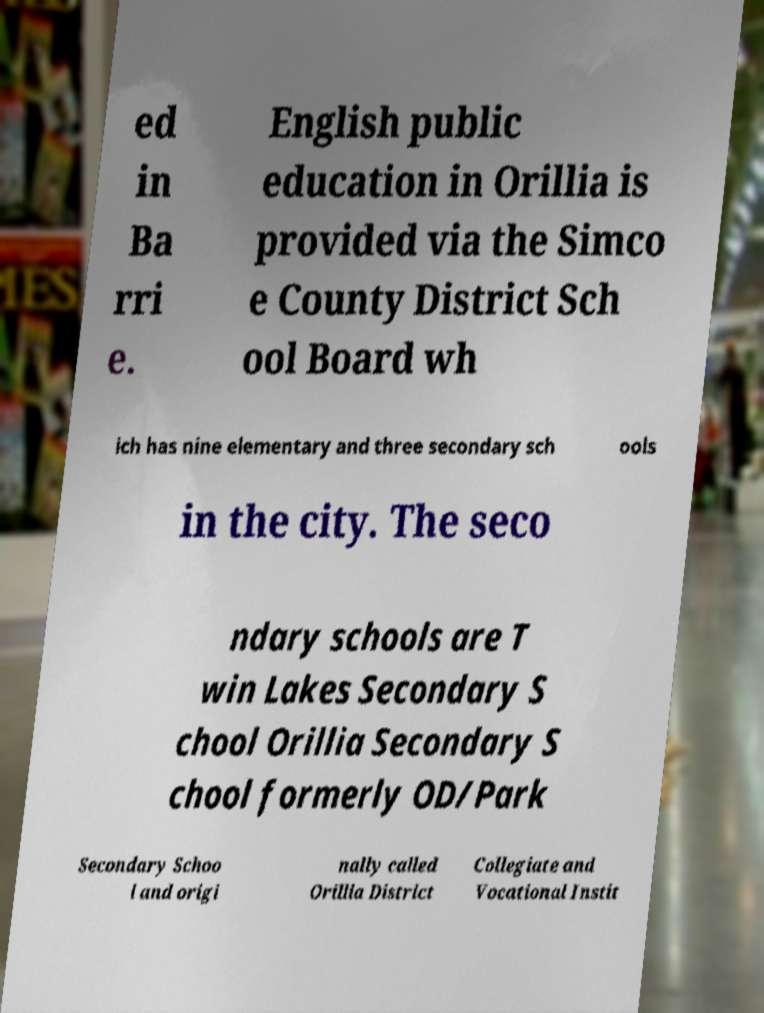What messages or text are displayed in this image? I need them in a readable, typed format. ed in Ba rri e. English public education in Orillia is provided via the Simco e County District Sch ool Board wh ich has nine elementary and three secondary sch ools in the city. The seco ndary schools are T win Lakes Secondary S chool Orillia Secondary S chool formerly OD/Park Secondary Schoo l and origi nally called Orillia District Collegiate and Vocational Instit 